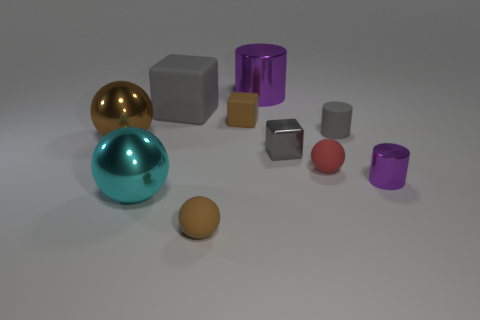There is a brown thing in front of the cyan sphere; does it have the same size as the cyan sphere?
Your answer should be very brief. No. How many red things have the same shape as the big purple object?
Make the answer very short. 0. What shape is the tiny purple metallic object?
Offer a terse response. Cylinder. Are there the same number of small red things right of the red rubber thing and metal cylinders?
Offer a terse response. No. Is there anything else that has the same material as the big cyan thing?
Provide a short and direct response. Yes. Is the large thing in front of the red rubber object made of the same material as the small purple cylinder?
Provide a succinct answer. Yes. Is the number of large metallic spheres that are right of the small gray matte thing less than the number of small gray metal cubes?
Provide a short and direct response. Yes. How many matte objects are either small red objects or tiny objects?
Your answer should be compact. 4. Is the color of the big block the same as the big cylinder?
Give a very brief answer. No. Are there any other things of the same color as the big shiny cylinder?
Give a very brief answer. Yes. 